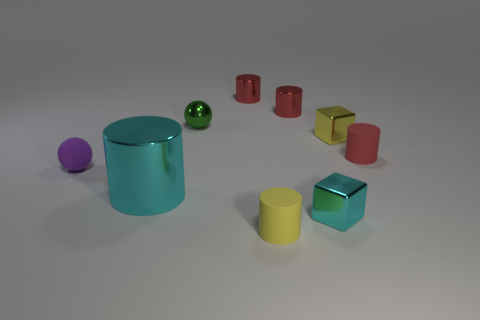Subtract all red blocks. How many red cylinders are left? 3 Subtract all brown cylinders. Subtract all red spheres. How many cylinders are left? 5 Subtract all cylinders. How many objects are left? 4 Add 4 yellow cylinders. How many yellow cylinders are left? 5 Add 4 tiny purple balls. How many tiny purple balls exist? 5 Subtract 1 yellow cubes. How many objects are left? 8 Subtract all red cylinders. Subtract all small red metallic cylinders. How many objects are left? 4 